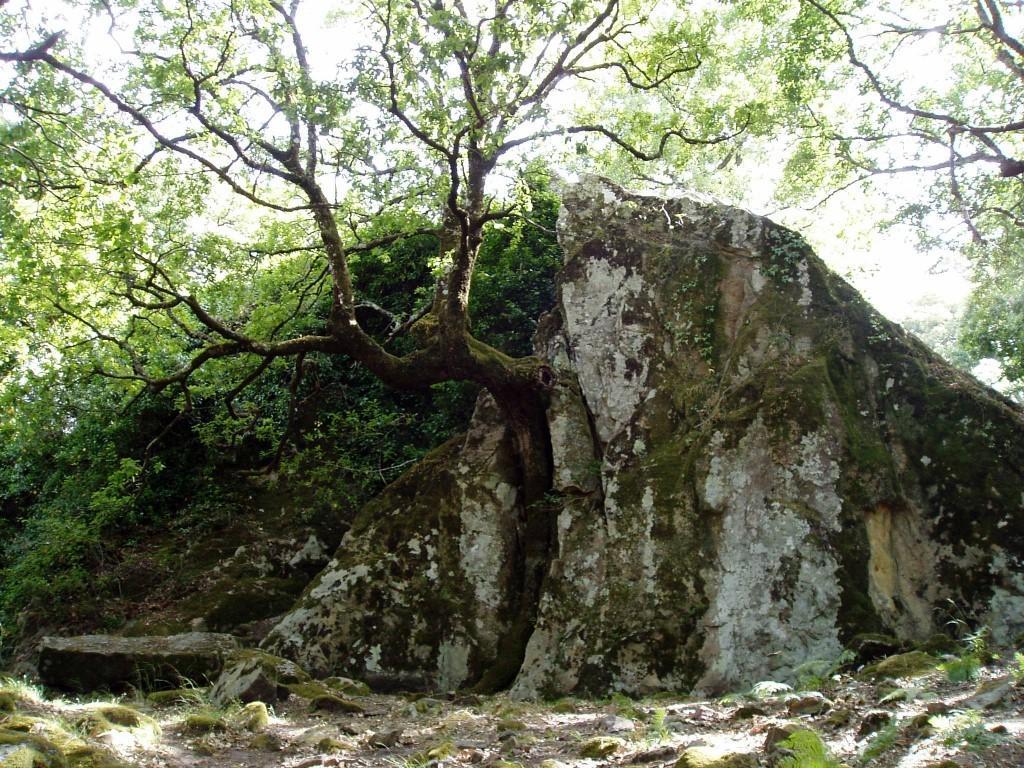Can you describe this image briefly? In the center of the image there is a rock and we can see trees. In the background there is sky. 